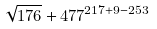<formula> <loc_0><loc_0><loc_500><loc_500>\sqrt { 1 7 6 } + 4 7 7 ^ { 2 1 7 + 9 - 2 5 3 }</formula> 